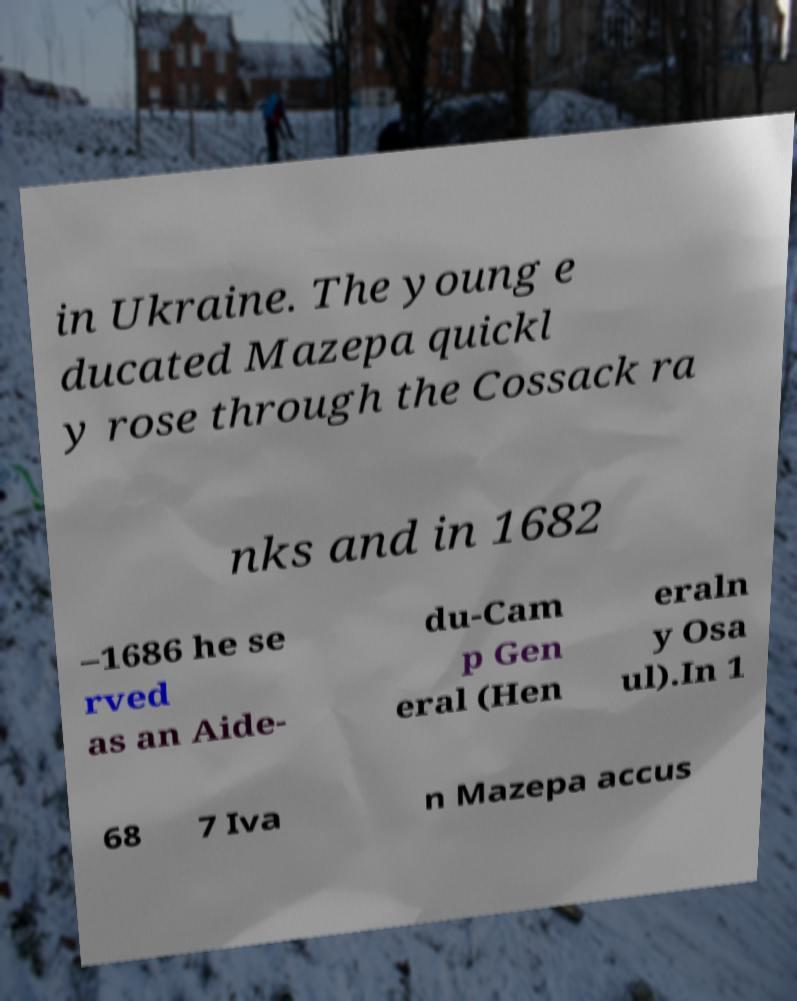I need the written content from this picture converted into text. Can you do that? in Ukraine. The young e ducated Mazepa quickl y rose through the Cossack ra nks and in 1682 –1686 he se rved as an Aide- du-Cam p Gen eral (Hen eraln y Osa ul).In 1 68 7 Iva n Mazepa accus 